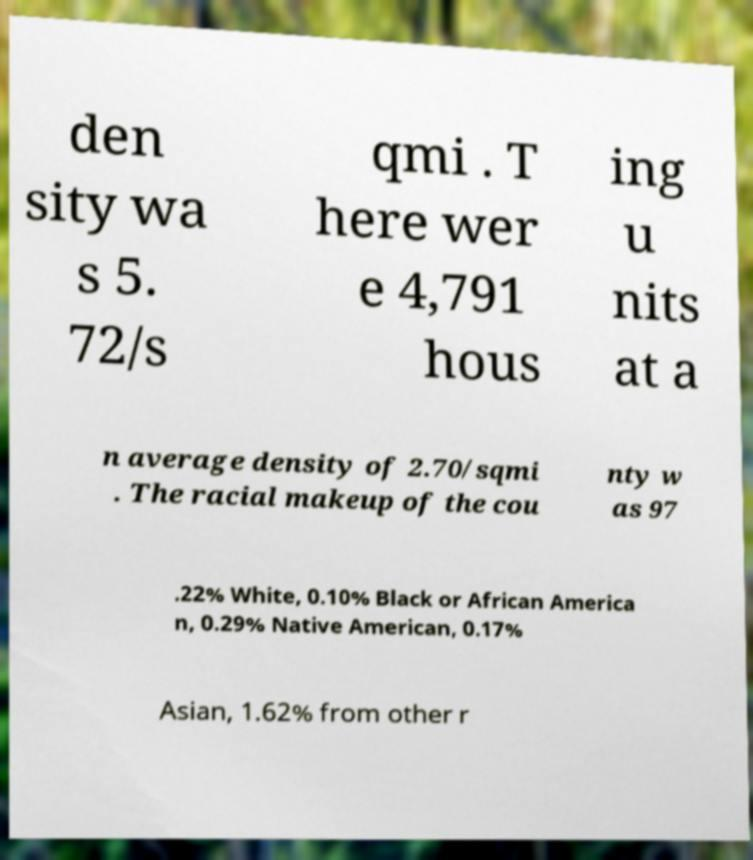For documentation purposes, I need the text within this image transcribed. Could you provide that? den sity wa s 5. 72/s qmi . T here wer e 4,791 hous ing u nits at a n average density of 2.70/sqmi . The racial makeup of the cou nty w as 97 .22% White, 0.10% Black or African America n, 0.29% Native American, 0.17% Asian, 1.62% from other r 